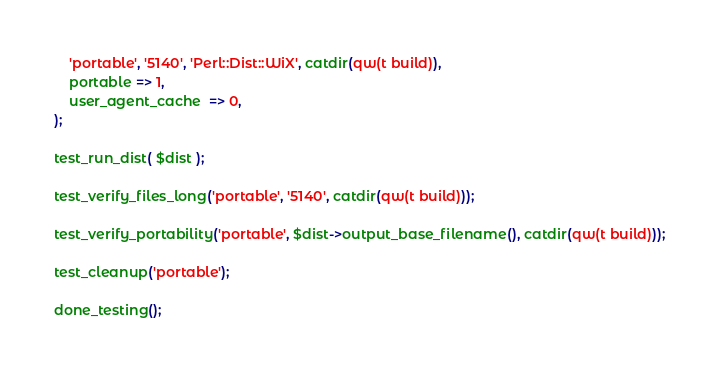Convert code to text. <code><loc_0><loc_0><loc_500><loc_500><_Perl_>	'portable', '5140', 'Perl::Dist::WiX', catdir(qw(t build)),
	portable => 1,
	user_agent_cache  => 0,
);

test_run_dist( $dist );

test_verify_files_long('portable', '5140', catdir(qw(t build)));

test_verify_portability('portable', $dist->output_base_filename(), catdir(qw(t build)));

test_cleanup('portable');

done_testing();

</code> 